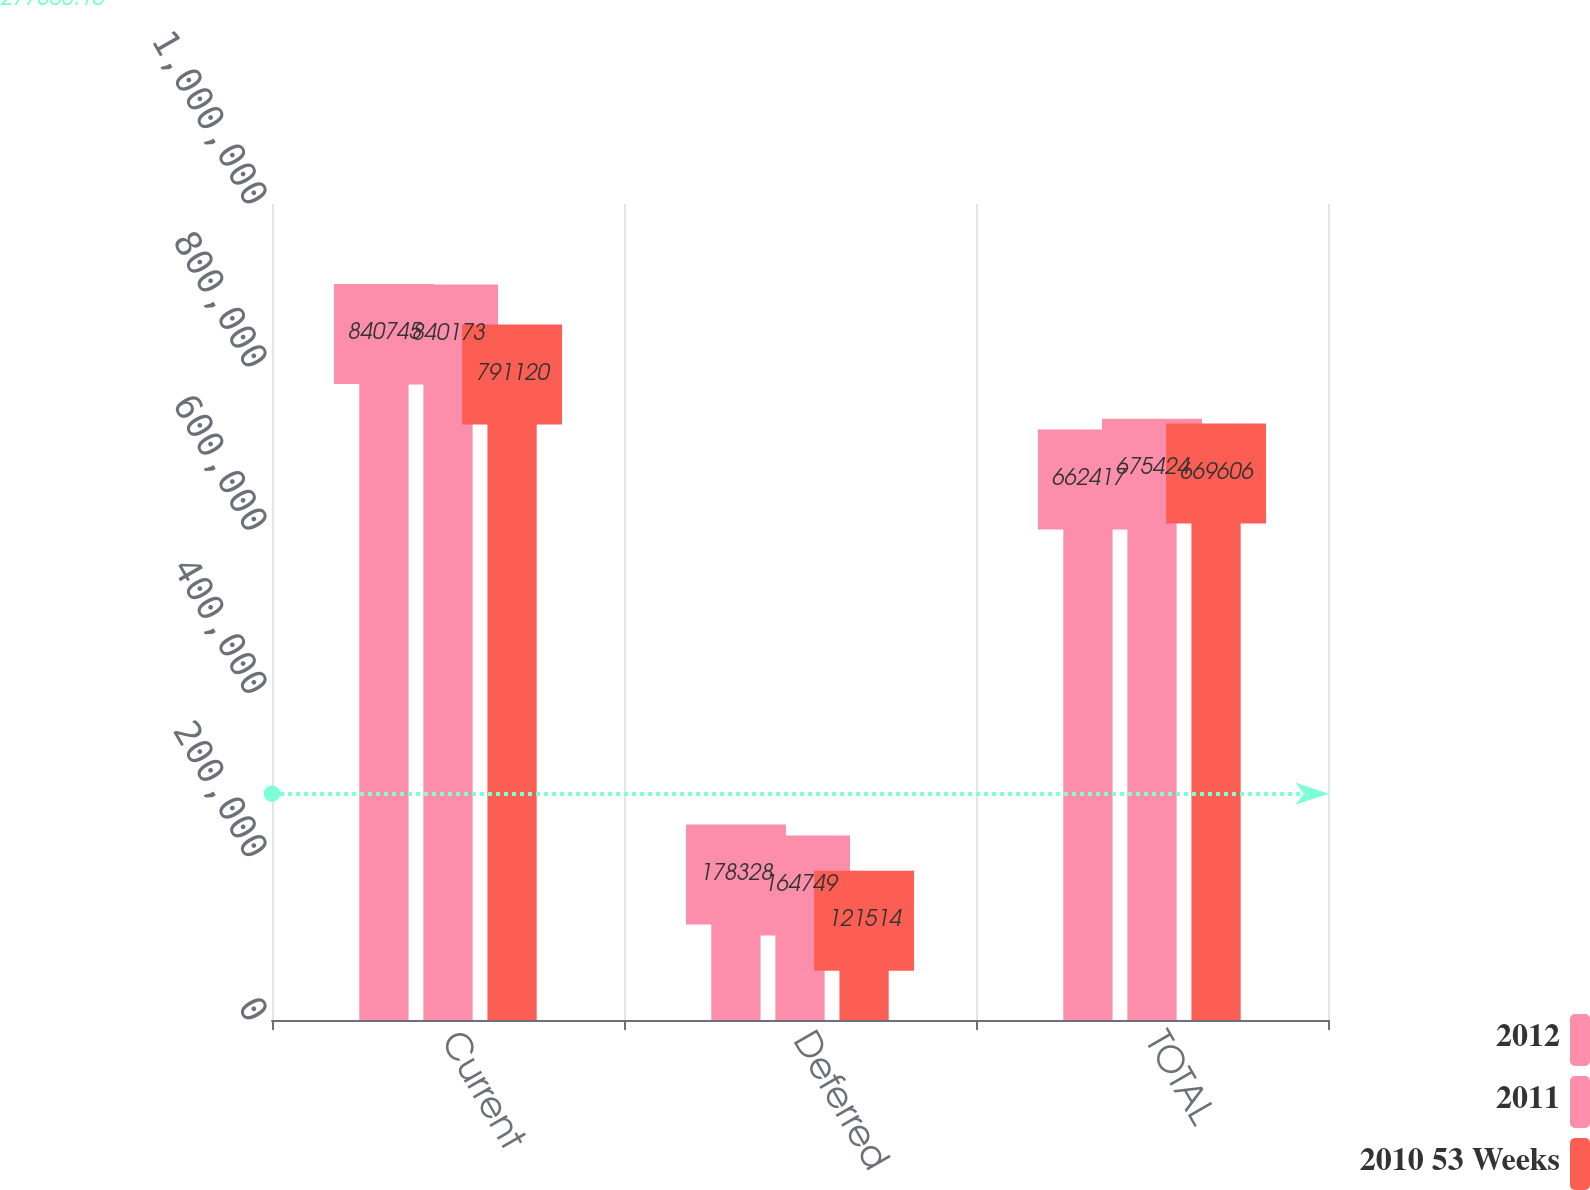Convert chart. <chart><loc_0><loc_0><loc_500><loc_500><stacked_bar_chart><ecel><fcel>Current<fcel>Deferred<fcel>TOTAL<nl><fcel>2012<fcel>840745<fcel>178328<fcel>662417<nl><fcel>2011<fcel>840173<fcel>164749<fcel>675424<nl><fcel>2010 53 Weeks<fcel>791120<fcel>121514<fcel>669606<nl></chart> 